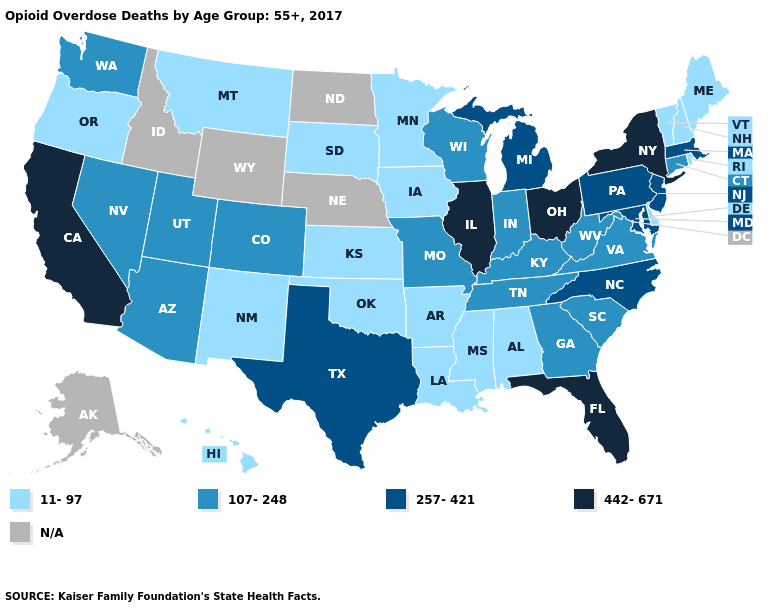What is the value of Tennessee?
Give a very brief answer. 107-248. Among the states that border Wisconsin , which have the highest value?
Keep it brief. Illinois. Name the states that have a value in the range 11-97?
Answer briefly. Alabama, Arkansas, Delaware, Hawaii, Iowa, Kansas, Louisiana, Maine, Minnesota, Mississippi, Montana, New Hampshire, New Mexico, Oklahoma, Oregon, Rhode Island, South Dakota, Vermont. Name the states that have a value in the range N/A?
Give a very brief answer. Alaska, Idaho, Nebraska, North Dakota, Wyoming. Among the states that border California , which have the highest value?
Give a very brief answer. Arizona, Nevada. Name the states that have a value in the range 257-421?
Keep it brief. Maryland, Massachusetts, Michigan, New Jersey, North Carolina, Pennsylvania, Texas. What is the lowest value in states that border Massachusetts?
Short answer required. 11-97. What is the lowest value in states that border Indiana?
Answer briefly. 107-248. Name the states that have a value in the range 257-421?
Keep it brief. Maryland, Massachusetts, Michigan, New Jersey, North Carolina, Pennsylvania, Texas. Name the states that have a value in the range 442-671?
Write a very short answer. California, Florida, Illinois, New York, Ohio. Does California have the highest value in the West?
Concise answer only. Yes. Name the states that have a value in the range N/A?
Short answer required. Alaska, Idaho, Nebraska, North Dakota, Wyoming. Does Vermont have the lowest value in the Northeast?
Quick response, please. Yes. Among the states that border Ohio , which have the lowest value?
Concise answer only. Indiana, Kentucky, West Virginia. 